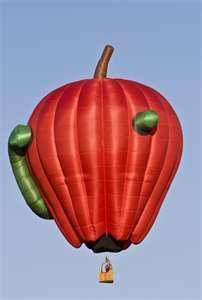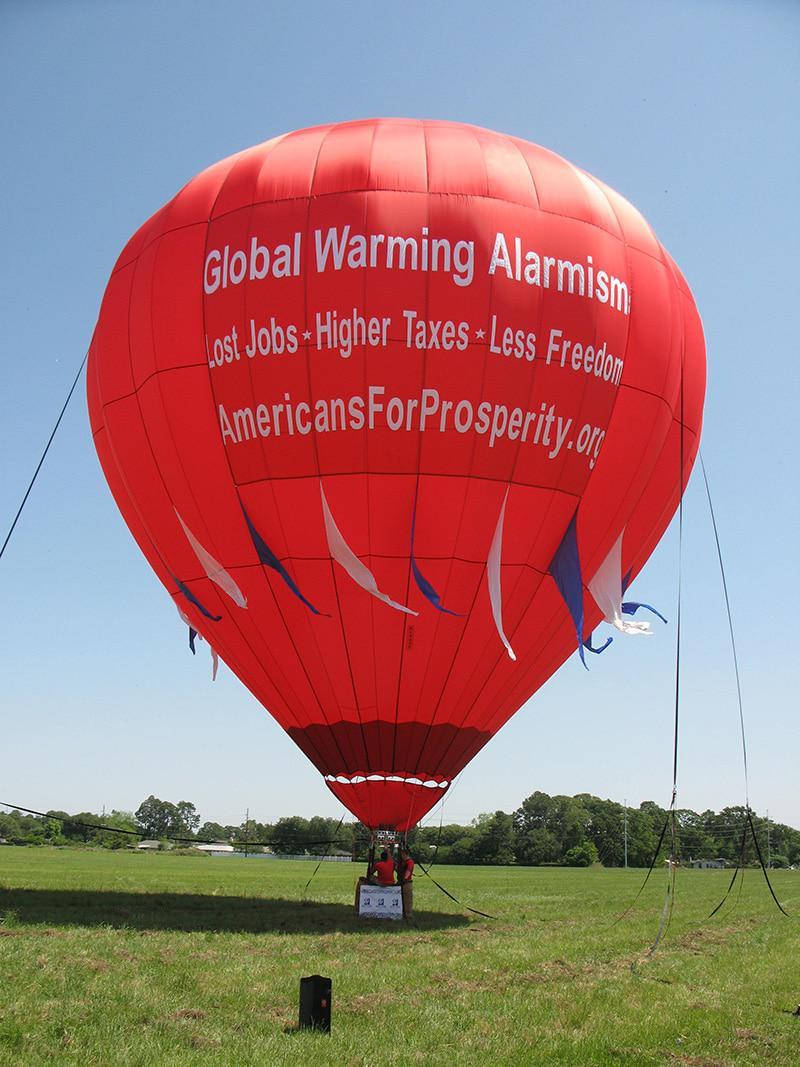The first image is the image on the left, the second image is the image on the right. Examine the images to the left and right. Is the description "One hot air balloon is on the ground and one is in the air." accurate? Answer yes or no. Yes. The first image is the image on the left, the second image is the image on the right. Given the left and right images, does the statement "The left image balloon is supposed to look like a red apple." hold true? Answer yes or no. Yes. 